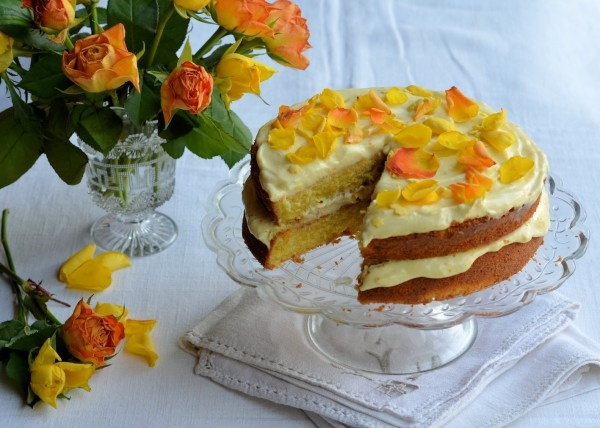Describe the objects in this image and their specific colors. I can see dining table in darkgray, lightblue, lavender, black, and darkgreen tones, cake in darkgreen, tan, orange, olive, and maroon tones, potted plant in darkgreen, black, darkgray, and olive tones, and vase in darkgreen, darkgray, and gray tones in this image. 